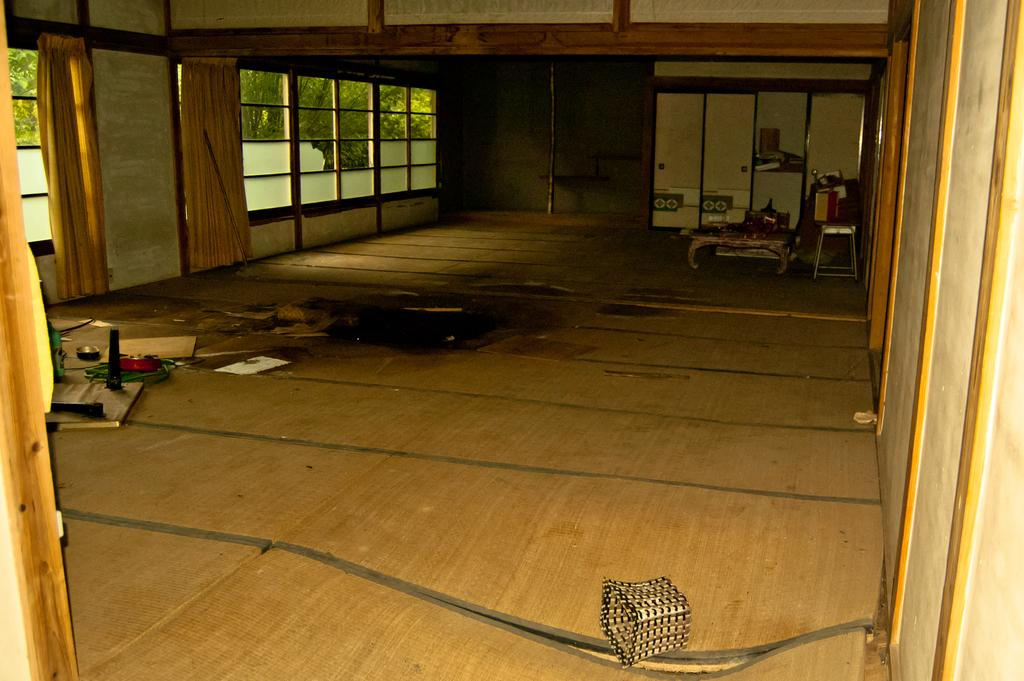What type of furniture is present in the image? There is a table and a stool in the image. What is the flooring material in the image? The flooring material is wooden, as objects are visible on the wooden floor. What type of window is present in the image? There are glass windows in the image, and leaves are visible through them. What type of window treatment is present in the image? There are curtains in the image. What type of storage furniture is present in the image? There are cupboards in the image. What is the income of the cub in the image? There is no cub present in the image, and therefore no income can be determined. What type of record is being played on the stool in the image? There is no record or music player present in the image, so it cannot be determined what type of record might be played. 